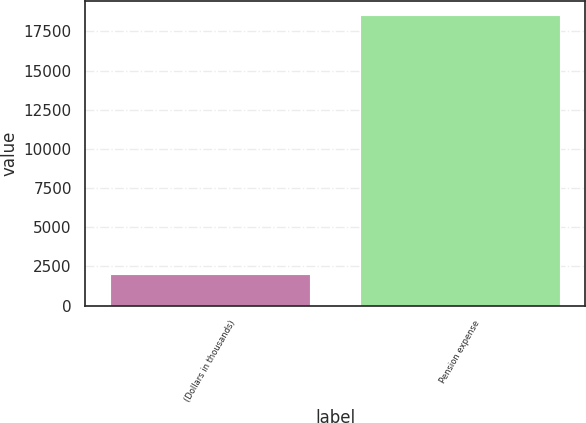Convert chart. <chart><loc_0><loc_0><loc_500><loc_500><bar_chart><fcel>(Dollars in thousands)<fcel>Pension expense<nl><fcel>2014<fcel>18543<nl></chart> 